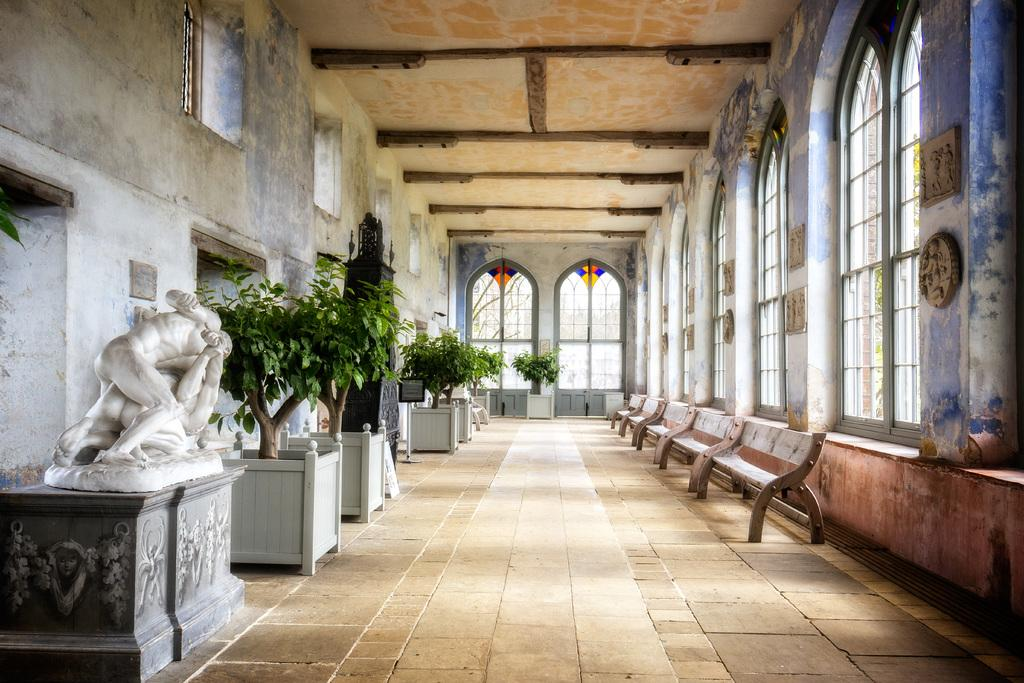Where was the image taken? The image was taken indoors. What can be seen on the right side of the image? There are benches on the right side of the image. What is located on the left side of the image? There are house plants and sculptures on the left side of the image. What architectural features are visible in the image? There is a roof, windows, and walls visible in the image. Can you hear the congregation laughing during the church service in the image? There is no church or congregation present in the image, and therefore no such activity can be observed. 